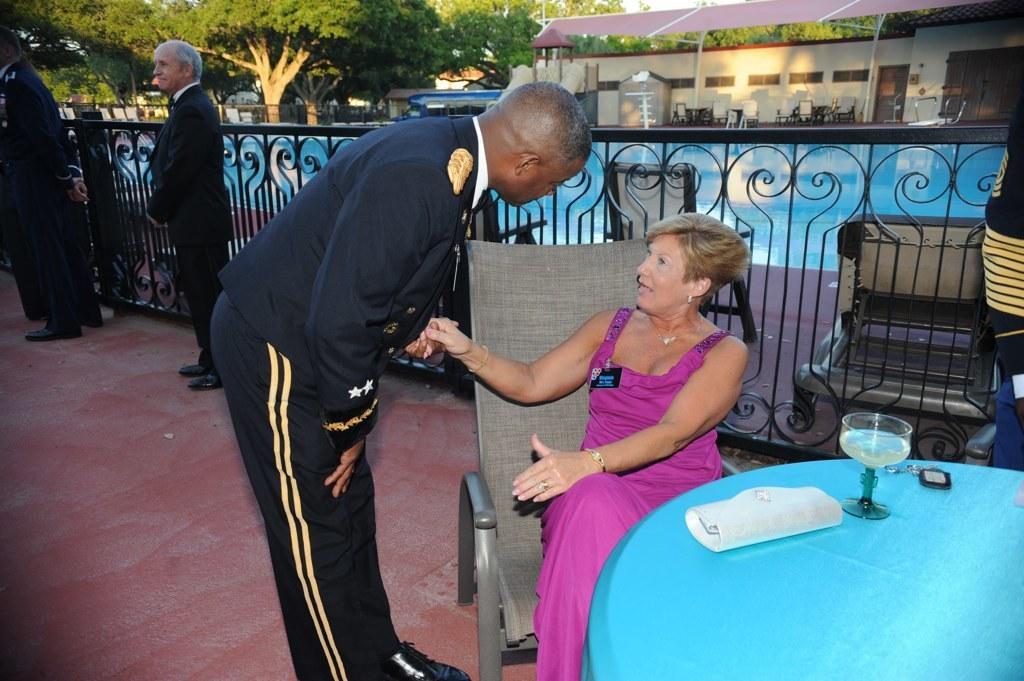In one or two sentences, can you explain what this image depicts? in the picture we can see a woman sitting on the chair and talking to person whose is standing and we can see a table in front of a woman and we can see a wallet and a glass placed on the table,here we can also see some persons standing little bit away,we can see a swimming pool near to persons,we can see trees we can also see the building near to them. 